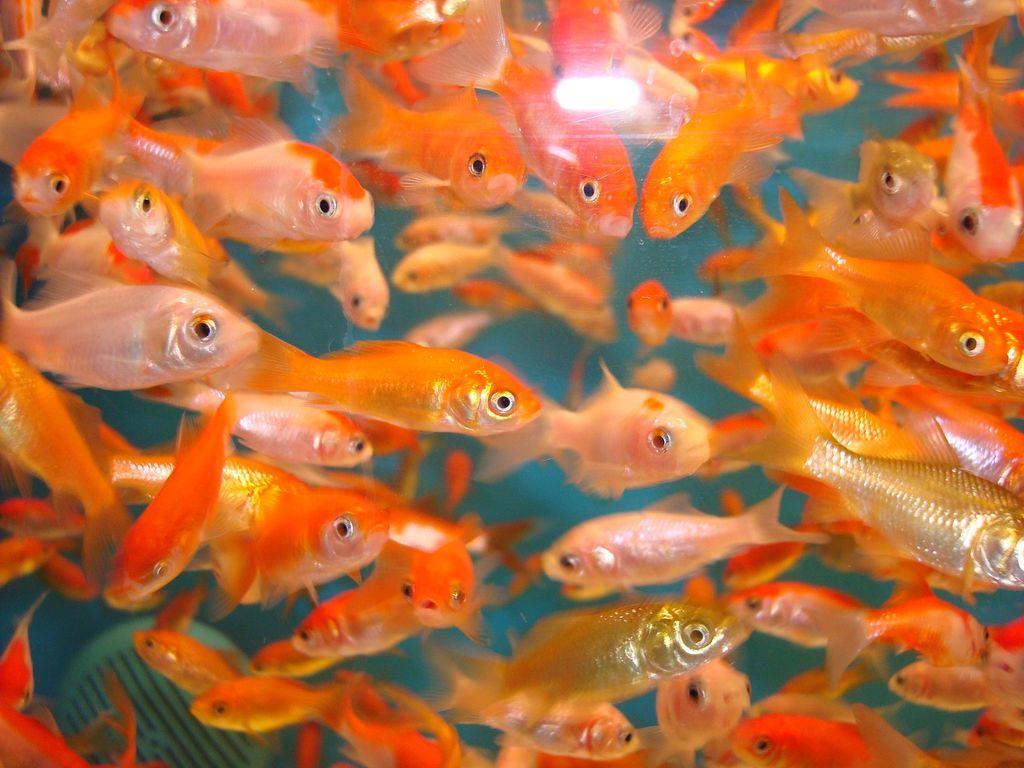How would you summarize this image in a sentence or two? There are white, orange and golden color fishes in the water. 